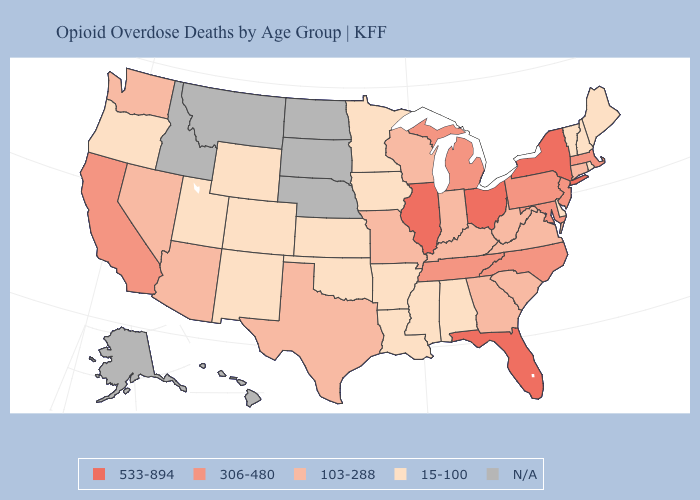Which states have the lowest value in the USA?
Be succinct. Alabama, Arkansas, Colorado, Delaware, Iowa, Kansas, Louisiana, Maine, Minnesota, Mississippi, New Hampshire, New Mexico, Oklahoma, Oregon, Rhode Island, Utah, Vermont, Wyoming. Among the states that border Nevada , which have the lowest value?
Keep it brief. Oregon, Utah. What is the value of Nevada?
Be succinct. 103-288. What is the lowest value in the USA?
Keep it brief. 15-100. What is the value of South Dakota?
Keep it brief. N/A. What is the value of Wyoming?
Concise answer only. 15-100. Name the states that have a value in the range 15-100?
Short answer required. Alabama, Arkansas, Colorado, Delaware, Iowa, Kansas, Louisiana, Maine, Minnesota, Mississippi, New Hampshire, New Mexico, Oklahoma, Oregon, Rhode Island, Utah, Vermont, Wyoming. Name the states that have a value in the range 15-100?
Give a very brief answer. Alabama, Arkansas, Colorado, Delaware, Iowa, Kansas, Louisiana, Maine, Minnesota, Mississippi, New Hampshire, New Mexico, Oklahoma, Oregon, Rhode Island, Utah, Vermont, Wyoming. Does the first symbol in the legend represent the smallest category?
Short answer required. No. Which states have the highest value in the USA?
Short answer required. Florida, Illinois, New York, Ohio. Does New York have the highest value in the Northeast?
Answer briefly. Yes. Among the states that border Georgia , does Alabama have the lowest value?
Concise answer only. Yes. 